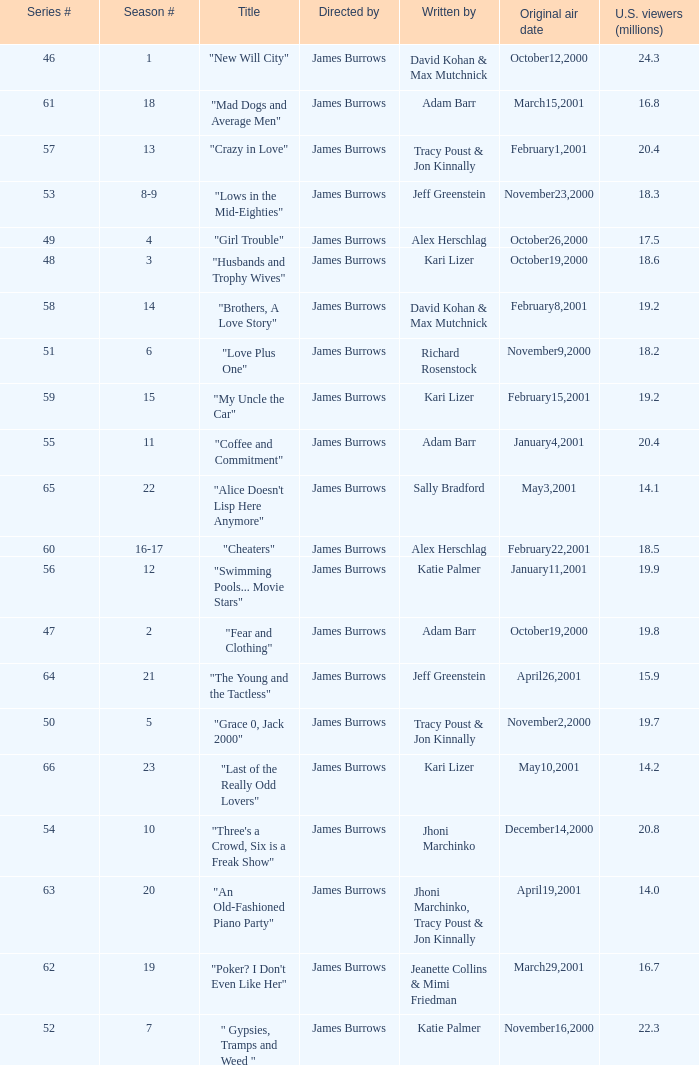Who wrote the episode titled "An Old-fashioned Piano Party"? Jhoni Marchinko, Tracy Poust & Jon Kinnally. 